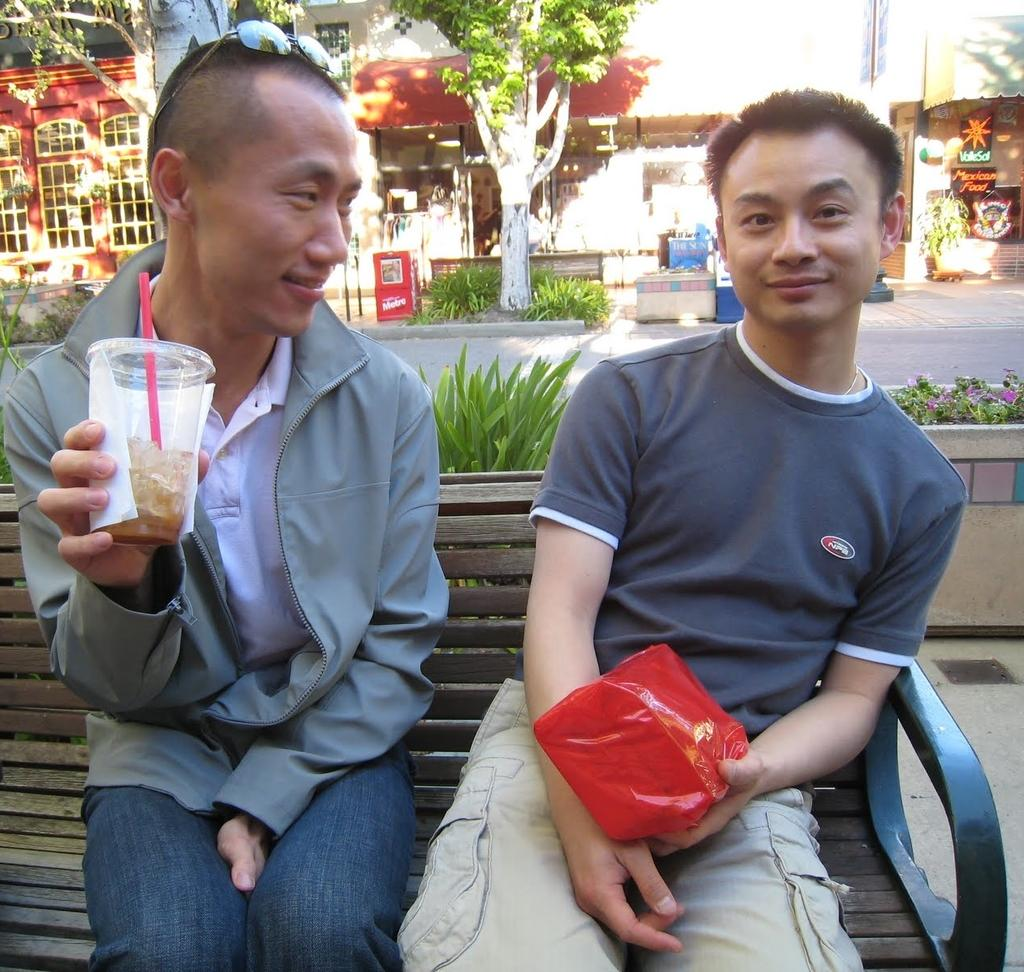How many people are sitting on the bench in the image? There are two people sitting on the bench in the image. What are the people holding in their hands? The people are holding objects in the image. What can be seen in the background of the image? There are stores, boards, plants, trees, and other objects in the background of the image. How many coils are visible on the bench in the image? There are no coils visible on the bench or in the image. Can you see any cows in the image? There are no cows present in the image. 